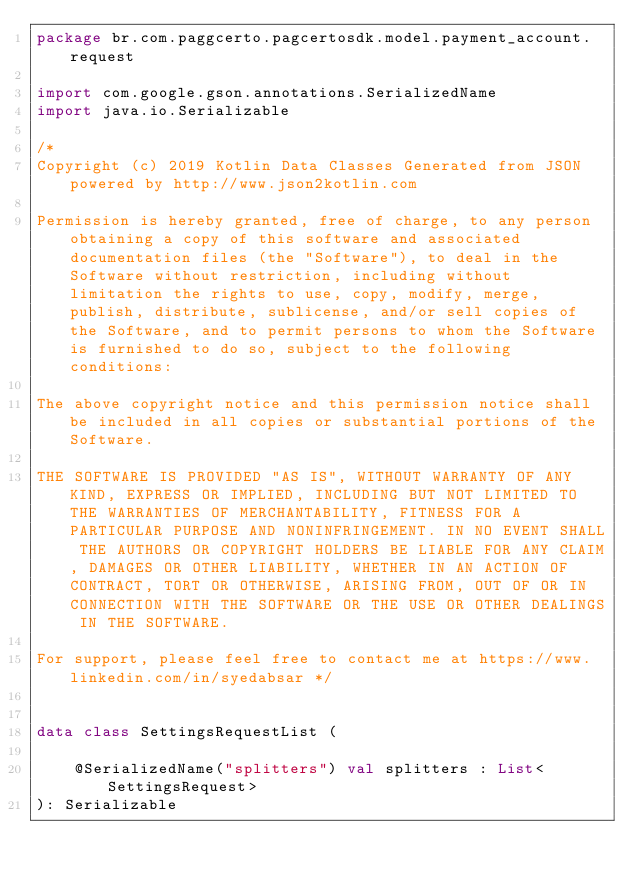<code> <loc_0><loc_0><loc_500><loc_500><_Kotlin_>package br.com.paggcerto.pagcertosdk.model.payment_account.request

import com.google.gson.annotations.SerializedName
import java.io.Serializable

/*
Copyright (c) 2019 Kotlin Data Classes Generated from JSON powered by http://www.json2kotlin.com

Permission is hereby granted, free of charge, to any person obtaining a copy of this software and associated documentation files (the "Software"), to deal in the Software without restriction, including without limitation the rights to use, copy, modify, merge, publish, distribute, sublicense, and/or sell copies of the Software, and to permit persons to whom the Software is furnished to do so, subject to the following conditions:

The above copyright notice and this permission notice shall be included in all copies or substantial portions of the Software.

THE SOFTWARE IS PROVIDED "AS IS", WITHOUT WARRANTY OF ANY KIND, EXPRESS OR IMPLIED, INCLUDING BUT NOT LIMITED TO THE WARRANTIES OF MERCHANTABILITY, FITNESS FOR A PARTICULAR PURPOSE AND NONINFRINGEMENT. IN NO EVENT SHALL THE AUTHORS OR COPYRIGHT HOLDERS BE LIABLE FOR ANY CLAIM, DAMAGES OR OTHER LIABILITY, WHETHER IN AN ACTION OF CONTRACT, TORT OR OTHERWISE, ARISING FROM, OUT OF OR IN CONNECTION WITH THE SOFTWARE OR THE USE OR OTHER DEALINGS IN THE SOFTWARE.

For support, please feel free to contact me at https://www.linkedin.com/in/syedabsar */


data class SettingsRequestList (

	@SerializedName("splitters") val splitters : List<SettingsRequest>
): Serializable</code> 